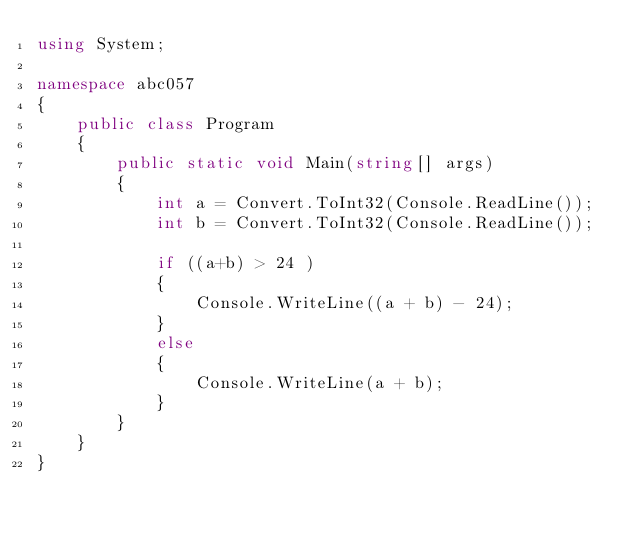Convert code to text. <code><loc_0><loc_0><loc_500><loc_500><_C#_>using System;

namespace abc057
{
    public class Program
    {
        public static void Main(string[] args)
        {
            int a = Convert.ToInt32(Console.ReadLine());
            int b = Convert.ToInt32(Console.ReadLine());

            if ((a+b) > 24 )
            {
                Console.WriteLine((a + b) - 24);
            }
            else
            {
                Console.WriteLine(a + b);
            }
        }
    }
}
</code> 